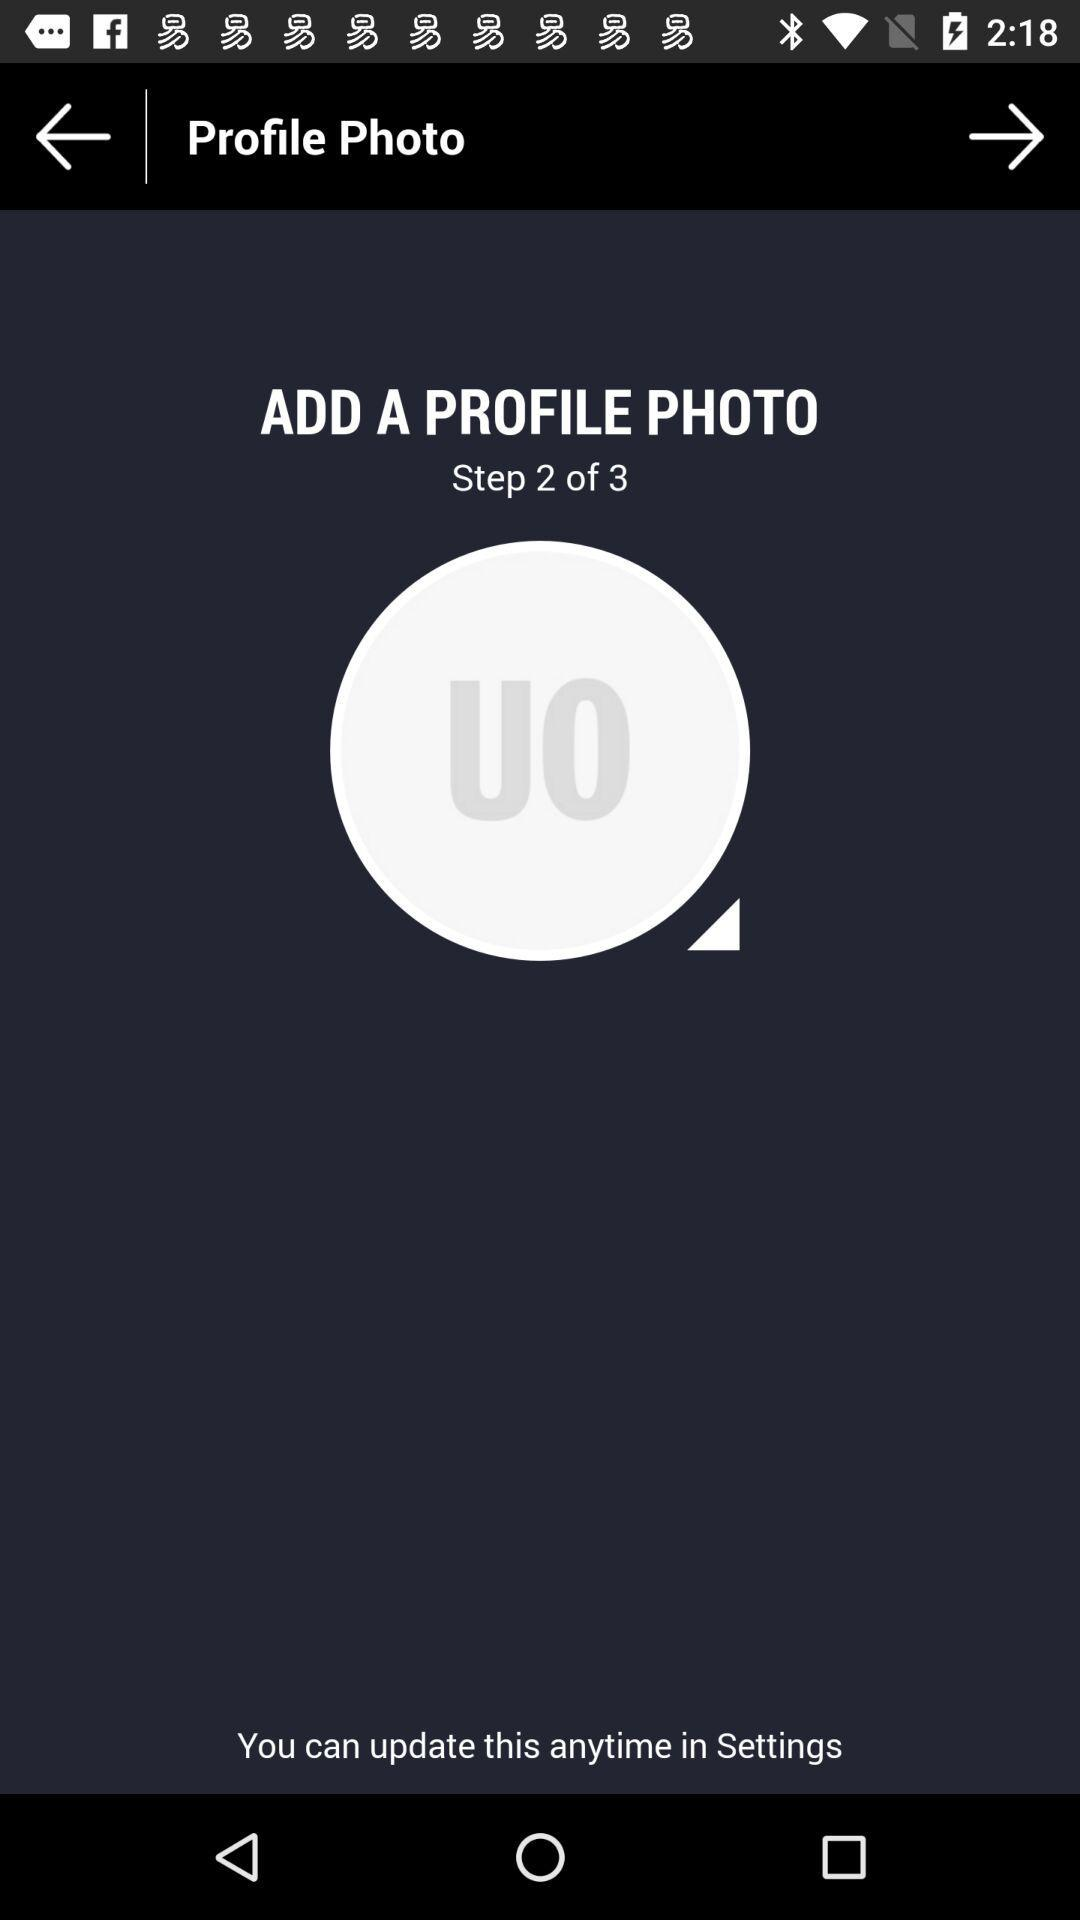How many steps are there in this process?
Answer the question using a single word or phrase. 3 